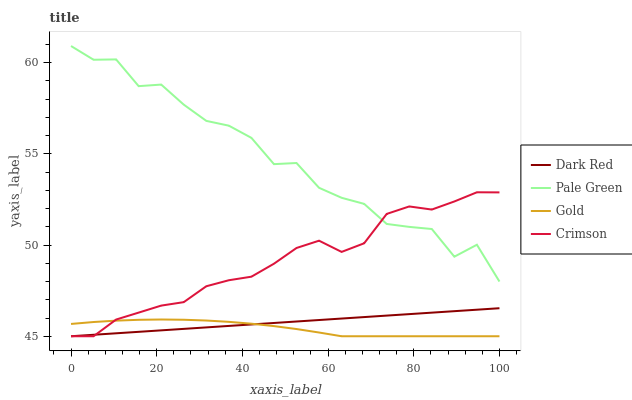Does Gold have the minimum area under the curve?
Answer yes or no. Yes. Does Pale Green have the maximum area under the curve?
Answer yes or no. Yes. Does Dark Red have the minimum area under the curve?
Answer yes or no. No. Does Dark Red have the maximum area under the curve?
Answer yes or no. No. Is Dark Red the smoothest?
Answer yes or no. Yes. Is Pale Green the roughest?
Answer yes or no. Yes. Is Pale Green the smoothest?
Answer yes or no. No. Is Dark Red the roughest?
Answer yes or no. No. Does Crimson have the lowest value?
Answer yes or no. Yes. Does Pale Green have the lowest value?
Answer yes or no. No. Does Pale Green have the highest value?
Answer yes or no. Yes. Does Dark Red have the highest value?
Answer yes or no. No. Is Dark Red less than Pale Green?
Answer yes or no. Yes. Is Pale Green greater than Gold?
Answer yes or no. Yes. Does Gold intersect Dark Red?
Answer yes or no. Yes. Is Gold less than Dark Red?
Answer yes or no. No. Is Gold greater than Dark Red?
Answer yes or no. No. Does Dark Red intersect Pale Green?
Answer yes or no. No. 